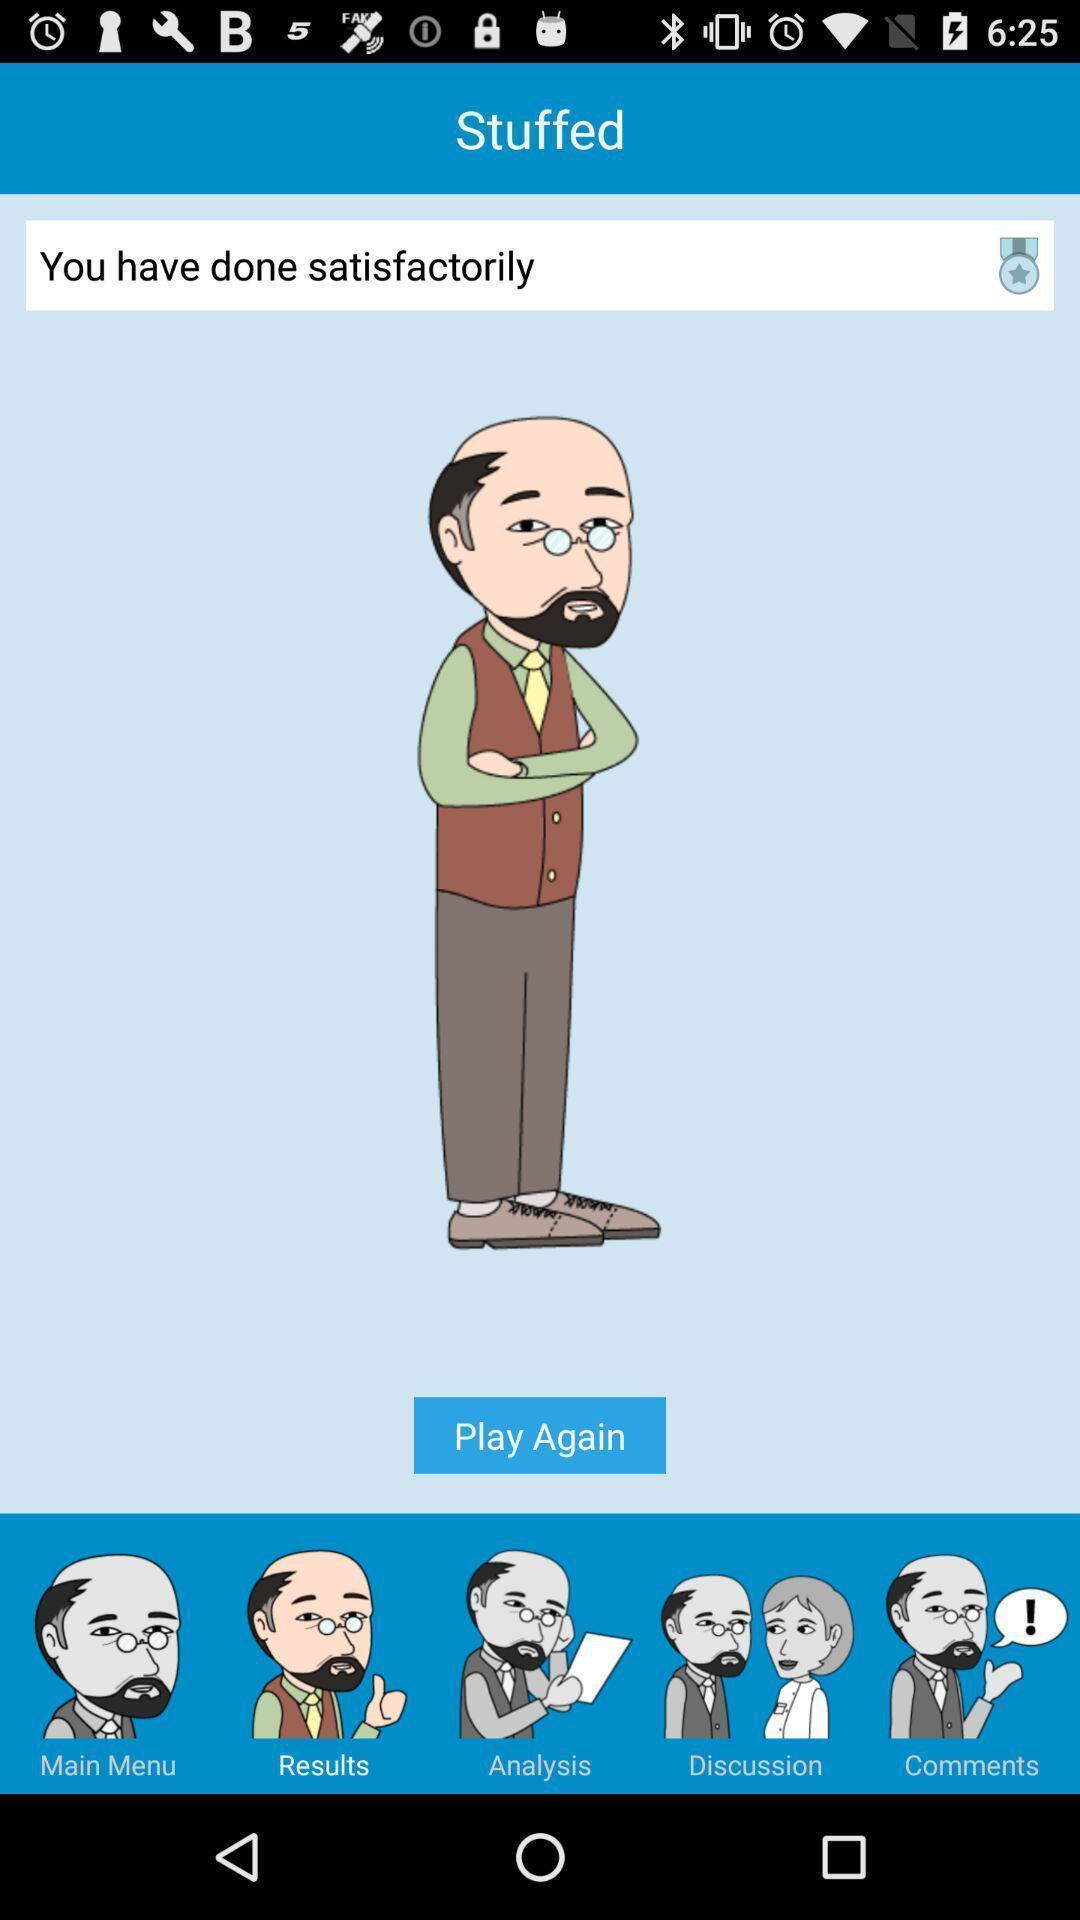Describe the key features of this screenshot. Window displaying a gaming app. 